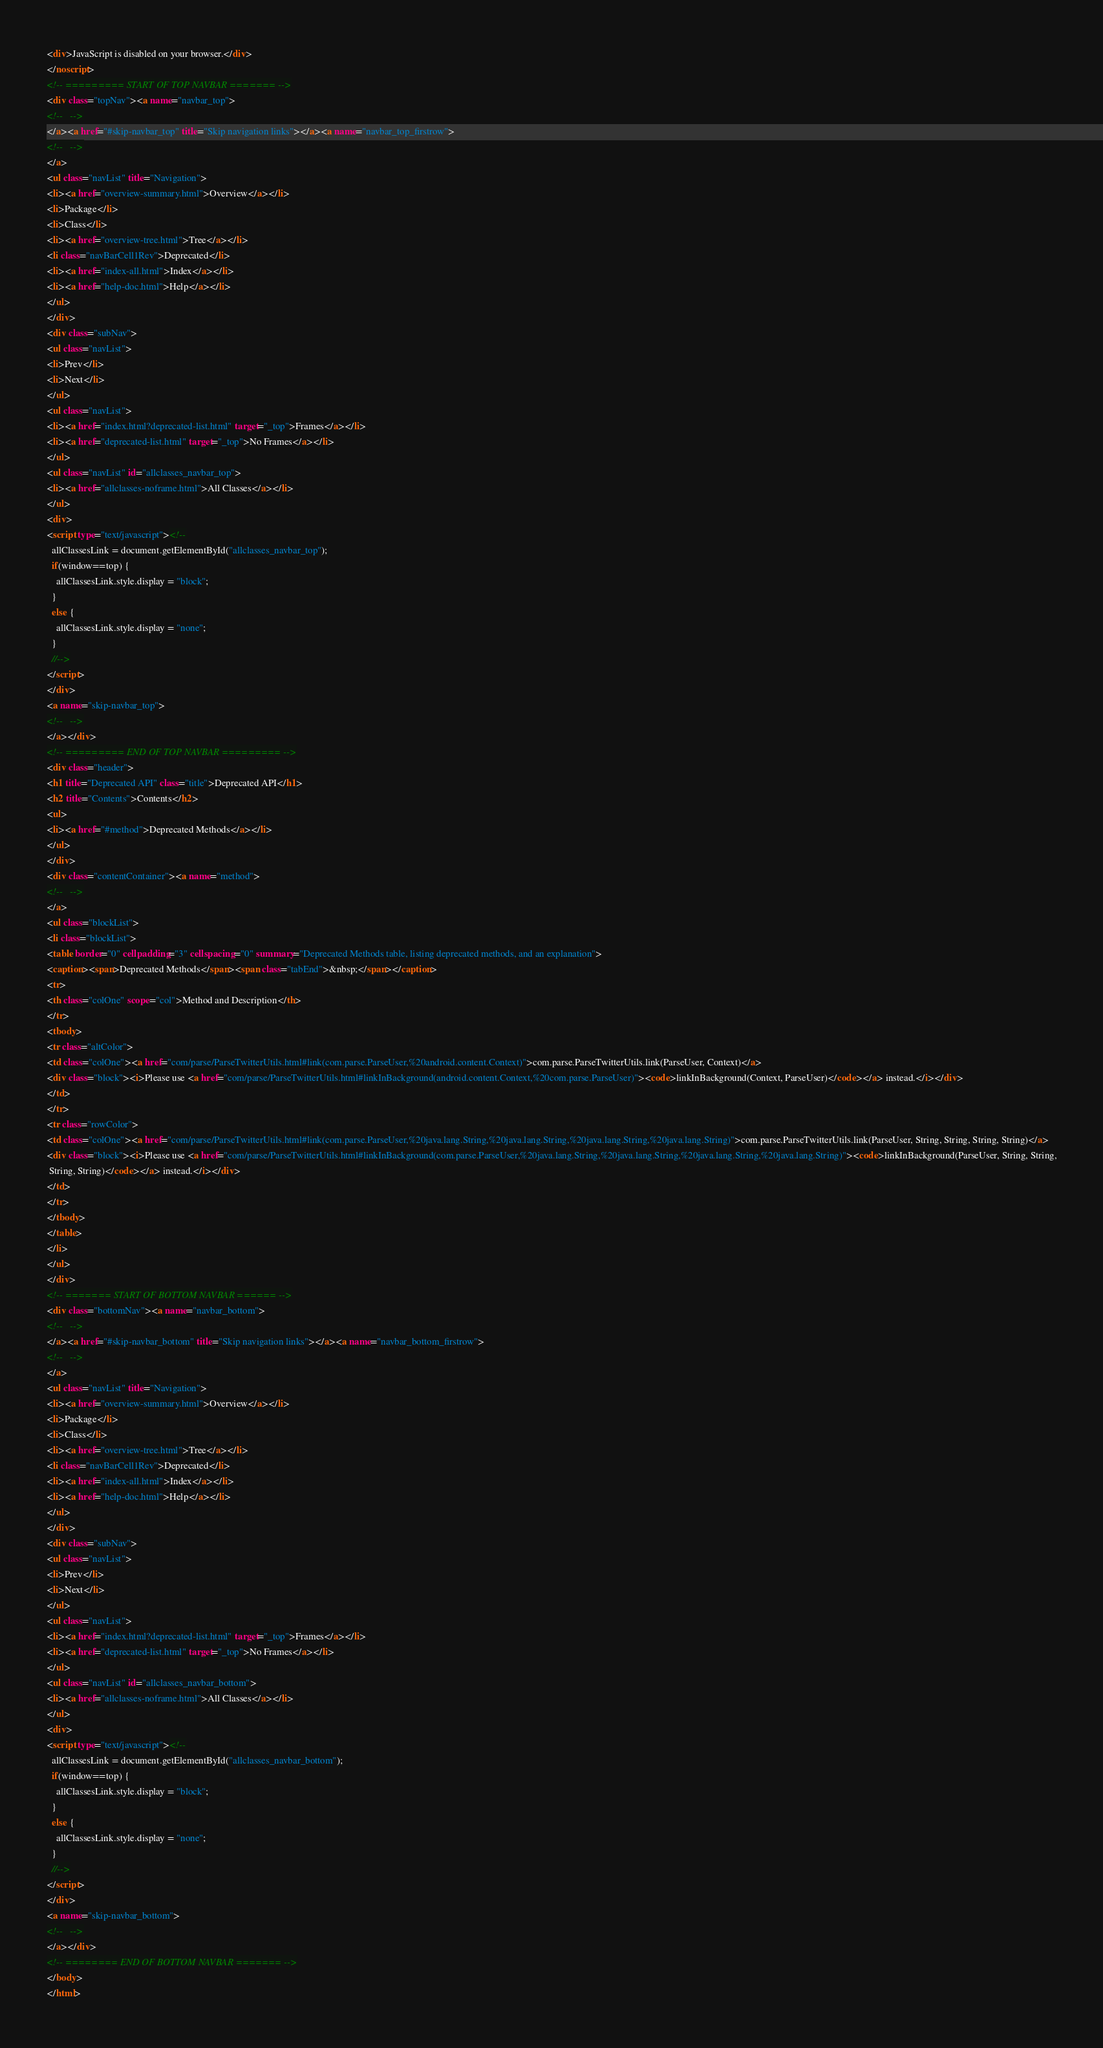<code> <loc_0><loc_0><loc_500><loc_500><_HTML_><div>JavaScript is disabled on your browser.</div>
</noscript>
<!-- ========= START OF TOP NAVBAR ======= -->
<div class="topNav"><a name="navbar_top">
<!--   -->
</a><a href="#skip-navbar_top" title="Skip navigation links"></a><a name="navbar_top_firstrow">
<!--   -->
</a>
<ul class="navList" title="Navigation">
<li><a href="overview-summary.html">Overview</a></li>
<li>Package</li>
<li>Class</li>
<li><a href="overview-tree.html">Tree</a></li>
<li class="navBarCell1Rev">Deprecated</li>
<li><a href="index-all.html">Index</a></li>
<li><a href="help-doc.html">Help</a></li>
</ul>
</div>
<div class="subNav">
<ul class="navList">
<li>Prev</li>
<li>Next</li>
</ul>
<ul class="navList">
<li><a href="index.html?deprecated-list.html" target="_top">Frames</a></li>
<li><a href="deprecated-list.html" target="_top">No Frames</a></li>
</ul>
<ul class="navList" id="allclasses_navbar_top">
<li><a href="allclasses-noframe.html">All Classes</a></li>
</ul>
<div>
<script type="text/javascript"><!--
  allClassesLink = document.getElementById("allclasses_navbar_top");
  if(window==top) {
    allClassesLink.style.display = "block";
  }
  else {
    allClassesLink.style.display = "none";
  }
  //-->
</script>
</div>
<a name="skip-navbar_top">
<!--   -->
</a></div>
<!-- ========= END OF TOP NAVBAR ========= -->
<div class="header">
<h1 title="Deprecated API" class="title">Deprecated API</h1>
<h2 title="Contents">Contents</h2>
<ul>
<li><a href="#method">Deprecated Methods</a></li>
</ul>
</div>
<div class="contentContainer"><a name="method">
<!--   -->
</a>
<ul class="blockList">
<li class="blockList">
<table border="0" cellpadding="3" cellspacing="0" summary="Deprecated Methods table, listing deprecated methods, and an explanation">
<caption><span>Deprecated Methods</span><span class="tabEnd">&nbsp;</span></caption>
<tr>
<th class="colOne" scope="col">Method and Description</th>
</tr>
<tbody>
<tr class="altColor">
<td class="colOne"><a href="com/parse/ParseTwitterUtils.html#link(com.parse.ParseUser,%20android.content.Context)">com.parse.ParseTwitterUtils.link(ParseUser, Context)</a>
<div class="block"><i>Please use <a href="com/parse/ParseTwitterUtils.html#linkInBackground(android.content.Context,%20com.parse.ParseUser)"><code>linkInBackground(Context, ParseUser)</code></a> instead.</i></div>
</td>
</tr>
<tr class="rowColor">
<td class="colOne"><a href="com/parse/ParseTwitterUtils.html#link(com.parse.ParseUser,%20java.lang.String,%20java.lang.String,%20java.lang.String,%20java.lang.String)">com.parse.ParseTwitterUtils.link(ParseUser, String, String, String, String)</a>
<div class="block"><i>Please use <a href="com/parse/ParseTwitterUtils.html#linkInBackground(com.parse.ParseUser,%20java.lang.String,%20java.lang.String,%20java.lang.String,%20java.lang.String)"><code>linkInBackground(ParseUser, String, String,
 String, String)</code></a> instead.</i></div>
</td>
</tr>
</tbody>
</table>
</li>
</ul>
</div>
<!-- ======= START OF BOTTOM NAVBAR ====== -->
<div class="bottomNav"><a name="navbar_bottom">
<!--   -->
</a><a href="#skip-navbar_bottom" title="Skip navigation links"></a><a name="navbar_bottom_firstrow">
<!--   -->
</a>
<ul class="navList" title="Navigation">
<li><a href="overview-summary.html">Overview</a></li>
<li>Package</li>
<li>Class</li>
<li><a href="overview-tree.html">Tree</a></li>
<li class="navBarCell1Rev">Deprecated</li>
<li><a href="index-all.html">Index</a></li>
<li><a href="help-doc.html">Help</a></li>
</ul>
</div>
<div class="subNav">
<ul class="navList">
<li>Prev</li>
<li>Next</li>
</ul>
<ul class="navList">
<li><a href="index.html?deprecated-list.html" target="_top">Frames</a></li>
<li><a href="deprecated-list.html" target="_top">No Frames</a></li>
</ul>
<ul class="navList" id="allclasses_navbar_bottom">
<li><a href="allclasses-noframe.html">All Classes</a></li>
</ul>
<div>
<script type="text/javascript"><!--
  allClassesLink = document.getElementById("allclasses_navbar_bottom");
  if(window==top) {
    allClassesLink.style.display = "block";
  }
  else {
    allClassesLink.style.display = "none";
  }
  //-->
</script>
</div>
<a name="skip-navbar_bottom">
<!--   -->
</a></div>
<!-- ======== END OF BOTTOM NAVBAR ======= -->
</body>
</html>
</code> 